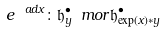Convert formula to latex. <formula><loc_0><loc_0><loc_500><loc_500>e ^ { \ a d x } \colon \mathfrak { h } ^ { \bullet } _ { y } \ m o r \mathfrak { h } ^ { \bullet } _ { \exp ( x ) \ast y }</formula> 